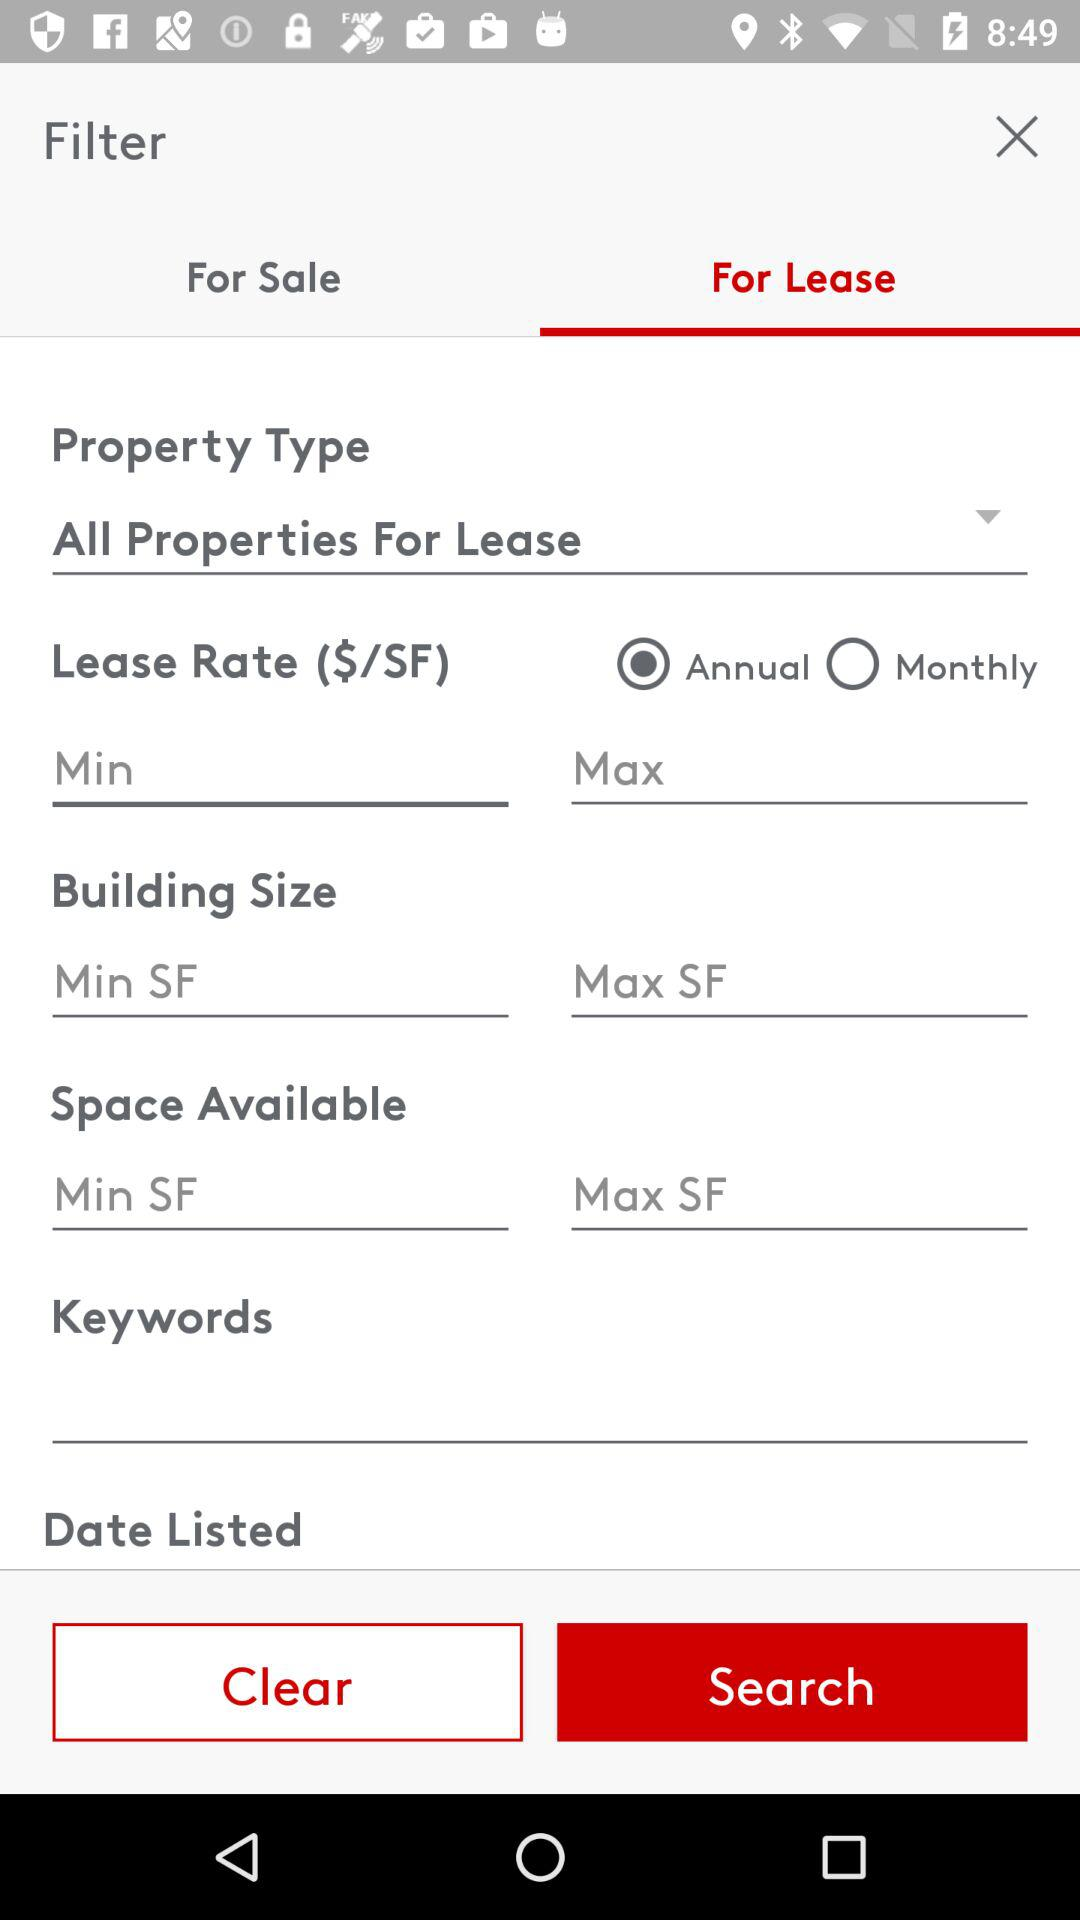Which option is selected? The selected options are "For Lease" and "Annual". 